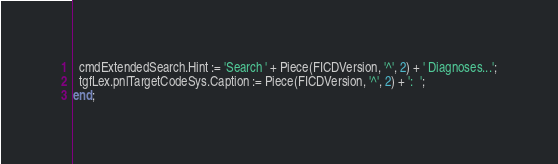<code> <loc_0><loc_0><loc_500><loc_500><_Pascal_>  cmdExtendedSearch.Hint := 'Search ' + Piece(FICDVersion, '^', 2) + ' Diagnoses...';
  tgfLex.pnlTargetCodeSys.Caption := Piece(FICDVersion, '^', 2) + ':  ';
end;
</code> 